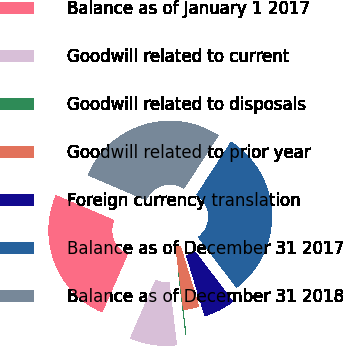Convert chart to OTSL. <chart><loc_0><loc_0><loc_500><loc_500><pie_chart><fcel>Balance as of January 1 2017<fcel>Goodwill related to current<fcel>Goodwill related to disposals<fcel>Goodwill related to prior year<fcel>Foreign currency translation<fcel>Balance as of December 31 2017<fcel>Balance as of December 31 2018<nl><fcel>24.89%<fcel>8.43%<fcel>0.02%<fcel>2.82%<fcel>5.63%<fcel>30.5%<fcel>27.7%<nl></chart> 